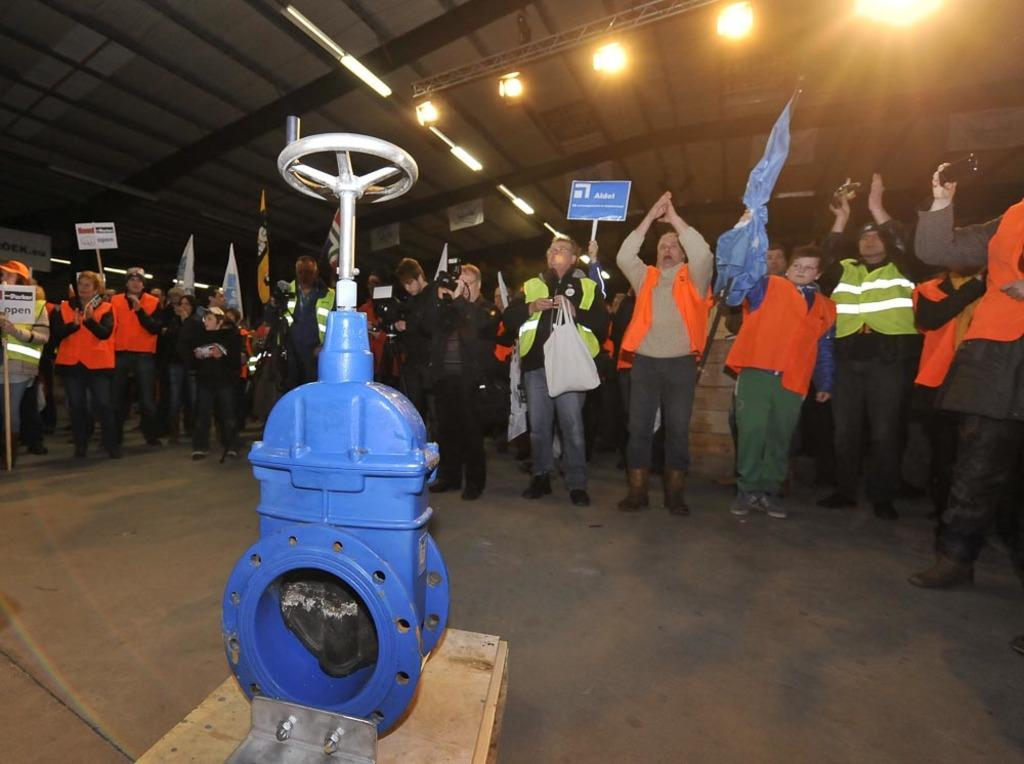What is the main object in the image? There is a machine in the image. What else can be seen in the image besides the machine? There is a group of people standing on the floor, flags, boards, lights, and jackets are visible in the image. What type of tomatoes can be seen hanging from the machine in the image? There are no tomatoes present in the image; the machine is the main object, and there are no tomatoes mentioned in the facts provided. 